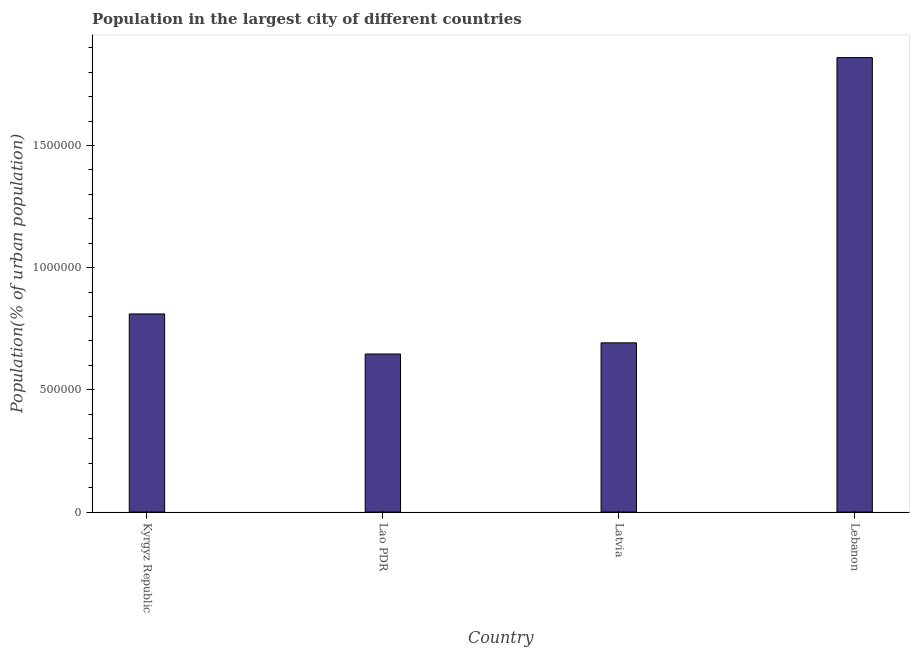What is the title of the graph?
Your answer should be very brief. Population in the largest city of different countries. What is the label or title of the X-axis?
Ensure brevity in your answer.  Country. What is the label or title of the Y-axis?
Your response must be concise. Population(% of urban population). What is the population in largest city in Latvia?
Your answer should be compact. 6.92e+05. Across all countries, what is the maximum population in largest city?
Your answer should be very brief. 1.86e+06. Across all countries, what is the minimum population in largest city?
Your answer should be very brief. 6.47e+05. In which country was the population in largest city maximum?
Provide a succinct answer. Lebanon. In which country was the population in largest city minimum?
Offer a very short reply. Lao PDR. What is the sum of the population in largest city?
Keep it short and to the point. 4.01e+06. What is the difference between the population in largest city in Kyrgyz Republic and Lebanon?
Offer a terse response. -1.05e+06. What is the average population in largest city per country?
Provide a succinct answer. 1.00e+06. What is the median population in largest city?
Your response must be concise. 7.51e+05. What is the ratio of the population in largest city in Latvia to that in Lebanon?
Offer a very short reply. 0.37. Is the difference between the population in largest city in Lao PDR and Lebanon greater than the difference between any two countries?
Your answer should be compact. Yes. What is the difference between the highest and the second highest population in largest city?
Offer a very short reply. 1.05e+06. Is the sum of the population in largest city in Kyrgyz Republic and Lao PDR greater than the maximum population in largest city across all countries?
Provide a short and direct response. No. What is the difference between the highest and the lowest population in largest city?
Give a very brief answer. 1.21e+06. How many bars are there?
Your response must be concise. 4. What is the Population(% of urban population) of Kyrgyz Republic?
Your answer should be compact. 8.11e+05. What is the Population(% of urban population) of Lao PDR?
Your response must be concise. 6.47e+05. What is the Population(% of urban population) in Latvia?
Provide a short and direct response. 6.92e+05. What is the Population(% of urban population) in Lebanon?
Offer a very short reply. 1.86e+06. What is the difference between the Population(% of urban population) in Kyrgyz Republic and Lao PDR?
Your response must be concise. 1.64e+05. What is the difference between the Population(% of urban population) in Kyrgyz Republic and Latvia?
Offer a terse response. 1.18e+05. What is the difference between the Population(% of urban population) in Kyrgyz Republic and Lebanon?
Provide a short and direct response. -1.05e+06. What is the difference between the Population(% of urban population) in Lao PDR and Latvia?
Offer a very short reply. -4.57e+04. What is the difference between the Population(% of urban population) in Lao PDR and Lebanon?
Offer a terse response. -1.21e+06. What is the difference between the Population(% of urban population) in Latvia and Lebanon?
Offer a very short reply. -1.17e+06. What is the ratio of the Population(% of urban population) in Kyrgyz Republic to that in Lao PDR?
Your response must be concise. 1.25. What is the ratio of the Population(% of urban population) in Kyrgyz Republic to that in Latvia?
Give a very brief answer. 1.17. What is the ratio of the Population(% of urban population) in Kyrgyz Republic to that in Lebanon?
Give a very brief answer. 0.44. What is the ratio of the Population(% of urban population) in Lao PDR to that in Latvia?
Make the answer very short. 0.93. What is the ratio of the Population(% of urban population) in Lao PDR to that in Lebanon?
Offer a very short reply. 0.35. What is the ratio of the Population(% of urban population) in Latvia to that in Lebanon?
Your answer should be compact. 0.37. 